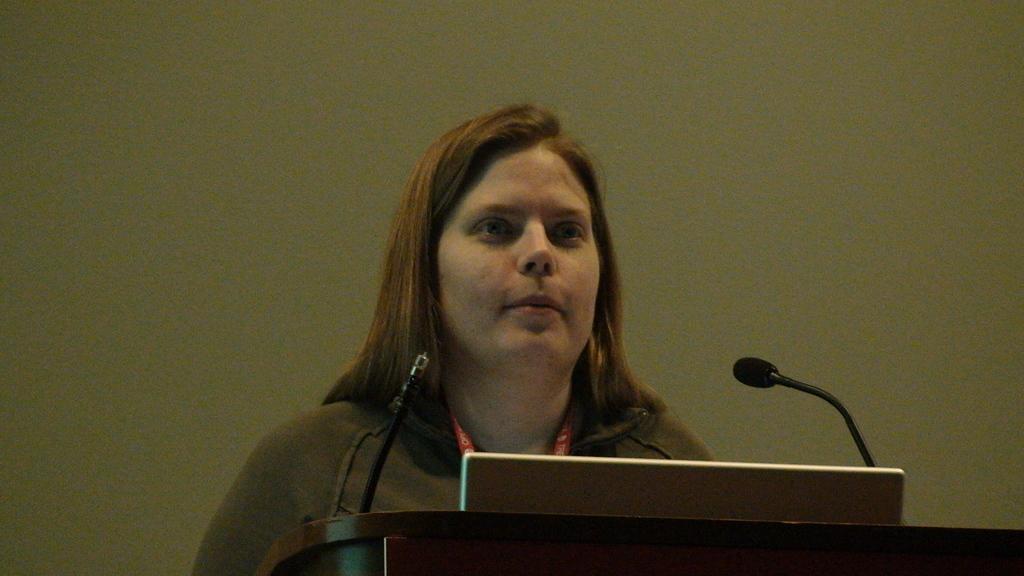Please provide a concise description of this image. In this image I can see a person wearing brown color shirt. In front I can see two microphones and a laptop, background the wall is in green color. 